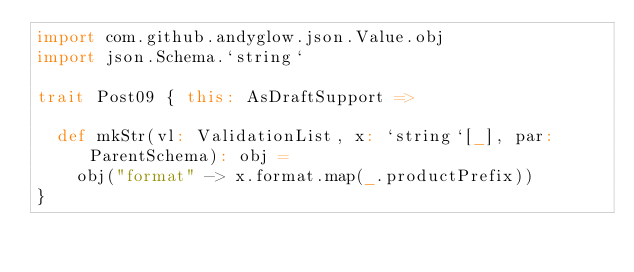<code> <loc_0><loc_0><loc_500><loc_500><_Scala_>import com.github.andyglow.json.Value.obj
import json.Schema.`string`

trait Post09 { this: AsDraftSupport =>

  def mkStr(vl: ValidationList, x: `string`[_], par: ParentSchema): obj =
    obj("format" -> x.format.map(_.productPrefix))
}
</code> 